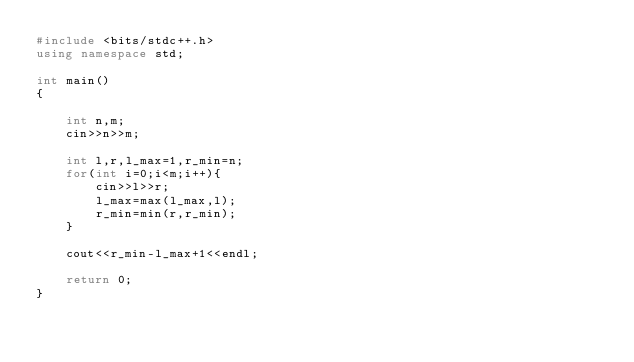Convert code to text. <code><loc_0><loc_0><loc_500><loc_500><_C++_>#include <bits/stdc++.h> 
using namespace std; 
 
int main() 
{ 

    int n,m;
    cin>>n>>m;

    int l,r,l_max=1,r_min=n;
    for(int i=0;i<m;i++){
        cin>>l>>r;
        l_max=max(l_max,l);
        r_min=min(r,r_min);
    }

    cout<<r_min-l_max+1<<endl;

    return 0; 
} 
</code> 